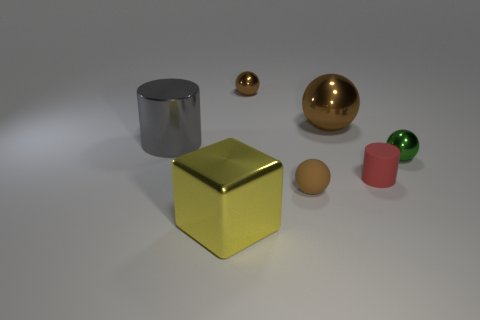How many brown spheres must be subtracted to get 1 brown spheres? 2 Subtract all yellow blocks. How many brown balls are left? 3 Add 1 large gray matte objects. How many objects exist? 8 Subtract all cubes. How many objects are left? 6 Add 3 big gray objects. How many big gray objects are left? 4 Add 7 brown spheres. How many brown spheres exist? 10 Subtract 2 brown balls. How many objects are left? 5 Subtract all large purple shiny things. Subtract all red matte objects. How many objects are left? 6 